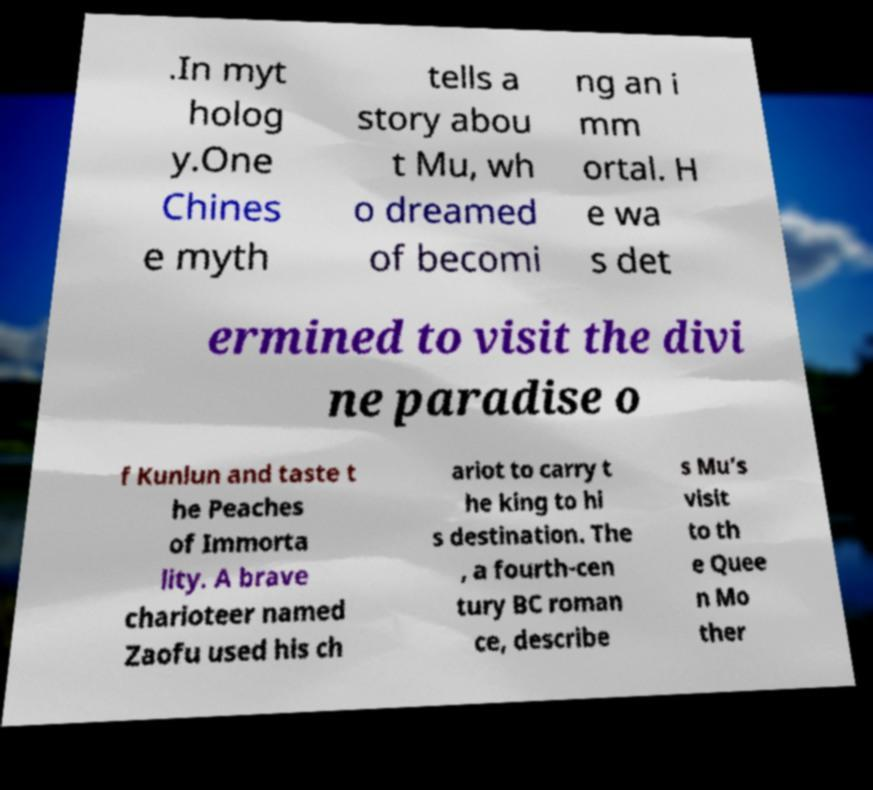Please identify and transcribe the text found in this image. .In myt holog y.One Chines e myth tells a story abou t Mu, wh o dreamed of becomi ng an i mm ortal. H e wa s det ermined to visit the divi ne paradise o f Kunlun and taste t he Peaches of Immorta lity. A brave charioteer named Zaofu used his ch ariot to carry t he king to hi s destination. The , a fourth-cen tury BC roman ce, describe s Mu’s visit to th e Quee n Mo ther 